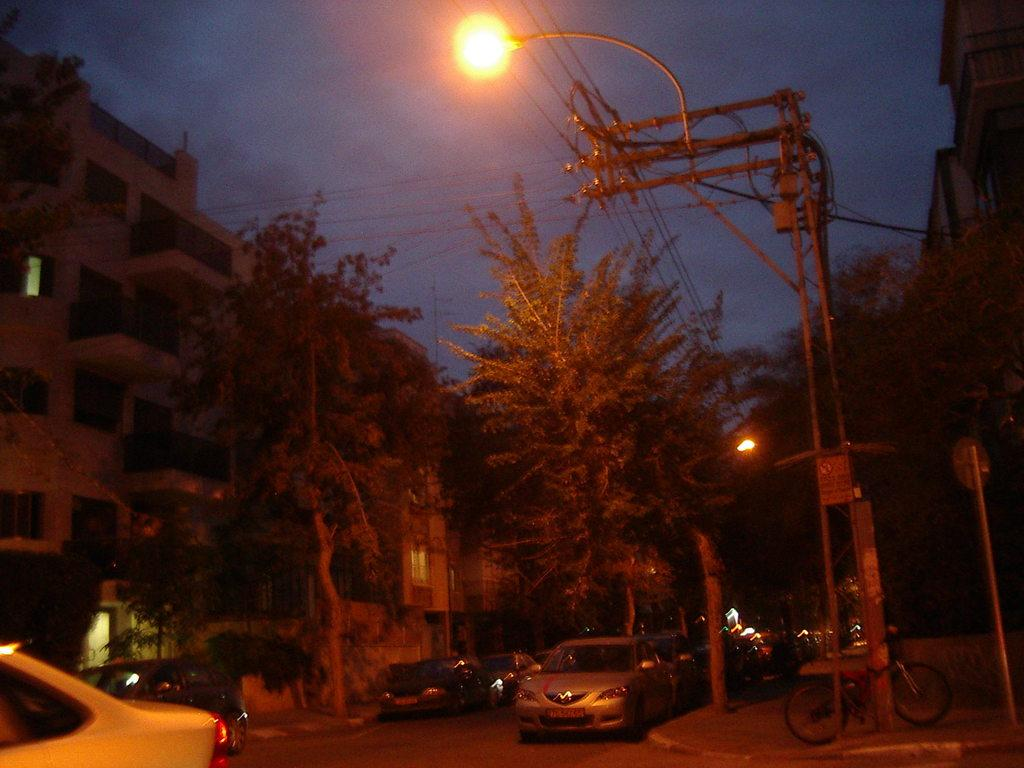What type of structures can be seen in the image? There are buildings in the image. What other natural elements are present in the image? There are trees in the image. What are the light sources in the image? There are light poles in the image. What mode of transportation can be seen in the image? There are cars on the road in the image. What is visible at the top of the image? The sky is visible at the top of the image. Who is the manager of the bulb in the image? There is no bulb present in the image, and therefore no manager is associated with it. What type of surprise can be seen in the image? There is no surprise present in the image; it features buildings, trees, light poles, cars, and the sky. 